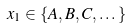Convert formula to latex. <formula><loc_0><loc_0><loc_500><loc_500>x _ { 1 } \in \{ A , B , C , \dots \}</formula> 